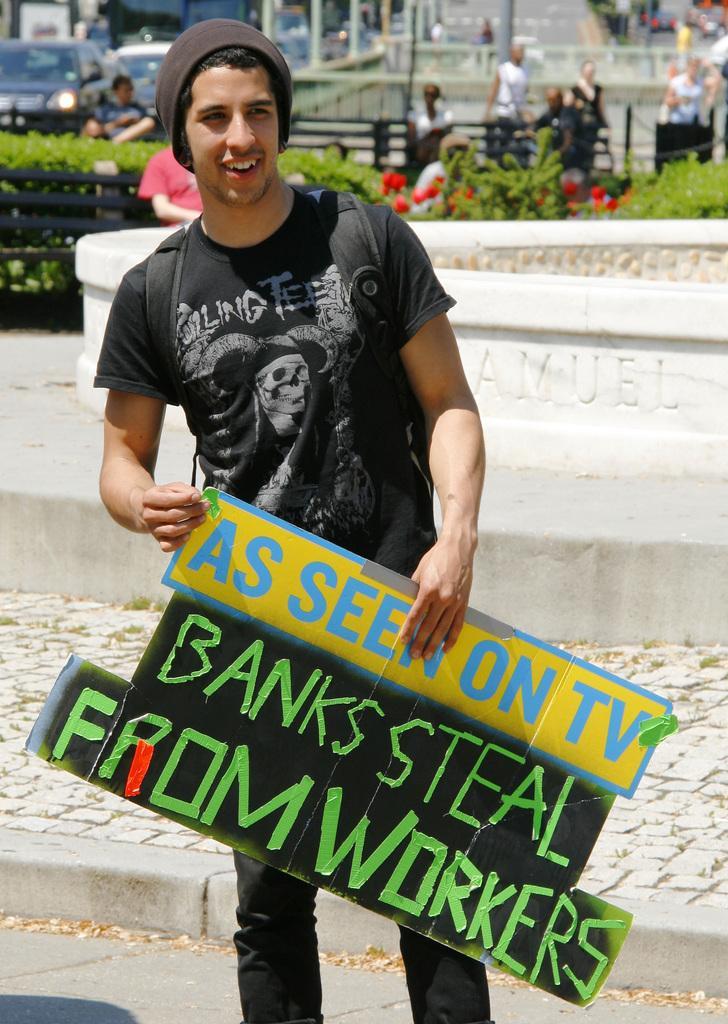In one or two sentences, can you explain what this image depicts? In the center of the image a man is standing and holding a board in his hand. And wearing a bag and a cap. In the background of the image some persons are sitting on a bench and plants flowers are there. At the bottom of the image ground is present. At the top right corner road is present. At the top left corner cars are there. At the top of the image moles are present. 